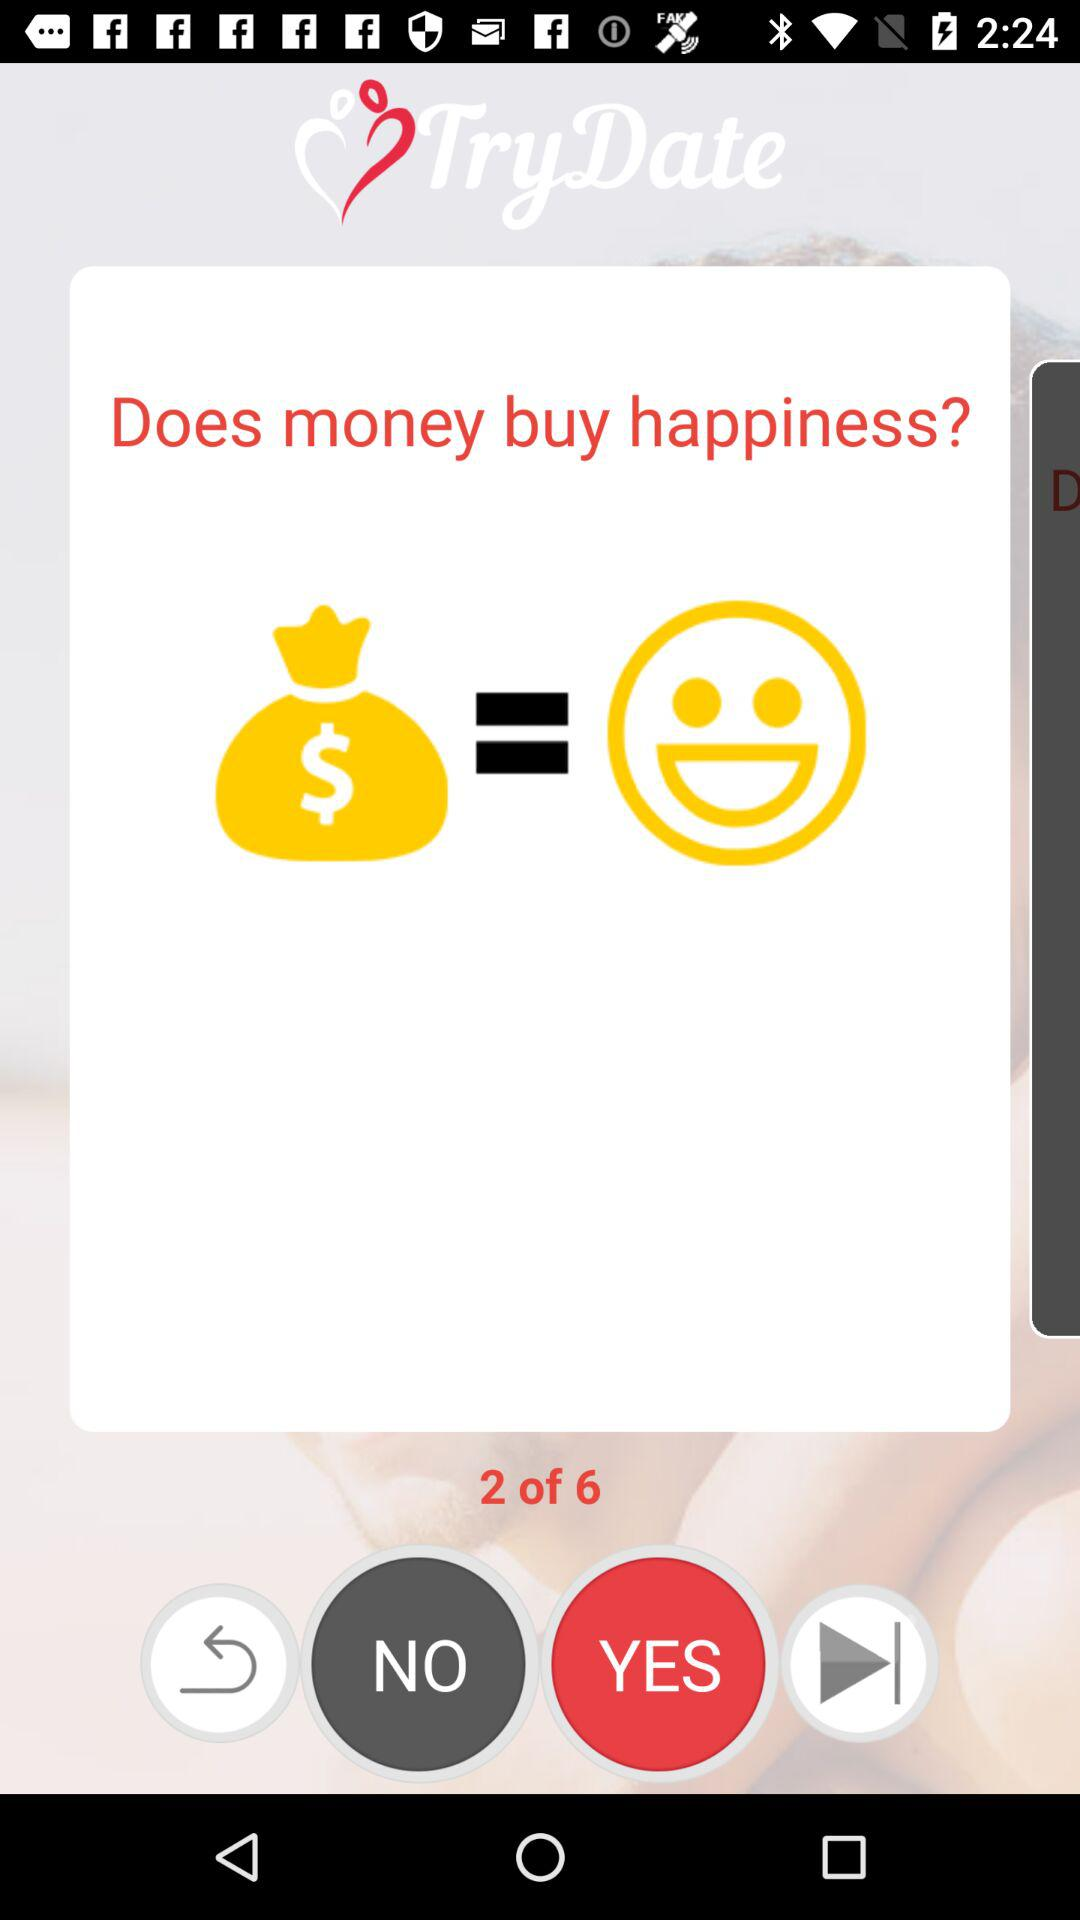To which question is the person responding? The person is responding to the second question. 